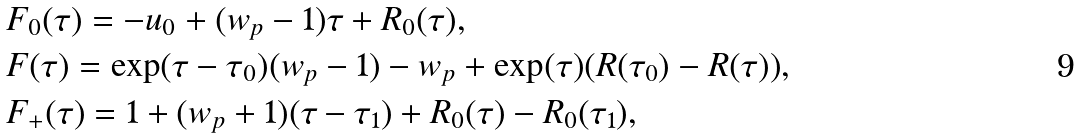Convert formula to latex. <formula><loc_0><loc_0><loc_500><loc_500>& F _ { 0 } ( \tau ) = - u _ { 0 } + ( w _ { p } - 1 ) \tau + R _ { 0 } ( \tau ) , \\ & F ( \tau ) = \exp ( \tau - \tau _ { 0 } ) ( w _ { p } - 1 ) - w _ { p } + \exp ( \tau ) ( R ( \tau _ { 0 } ) - R ( \tau ) ) , \\ & F _ { + } ( \tau ) = 1 + ( w _ { p } + 1 ) ( \tau - \tau _ { 1 } ) + R _ { 0 } ( \tau ) - R _ { 0 } ( \tau _ { 1 } ) ,</formula> 